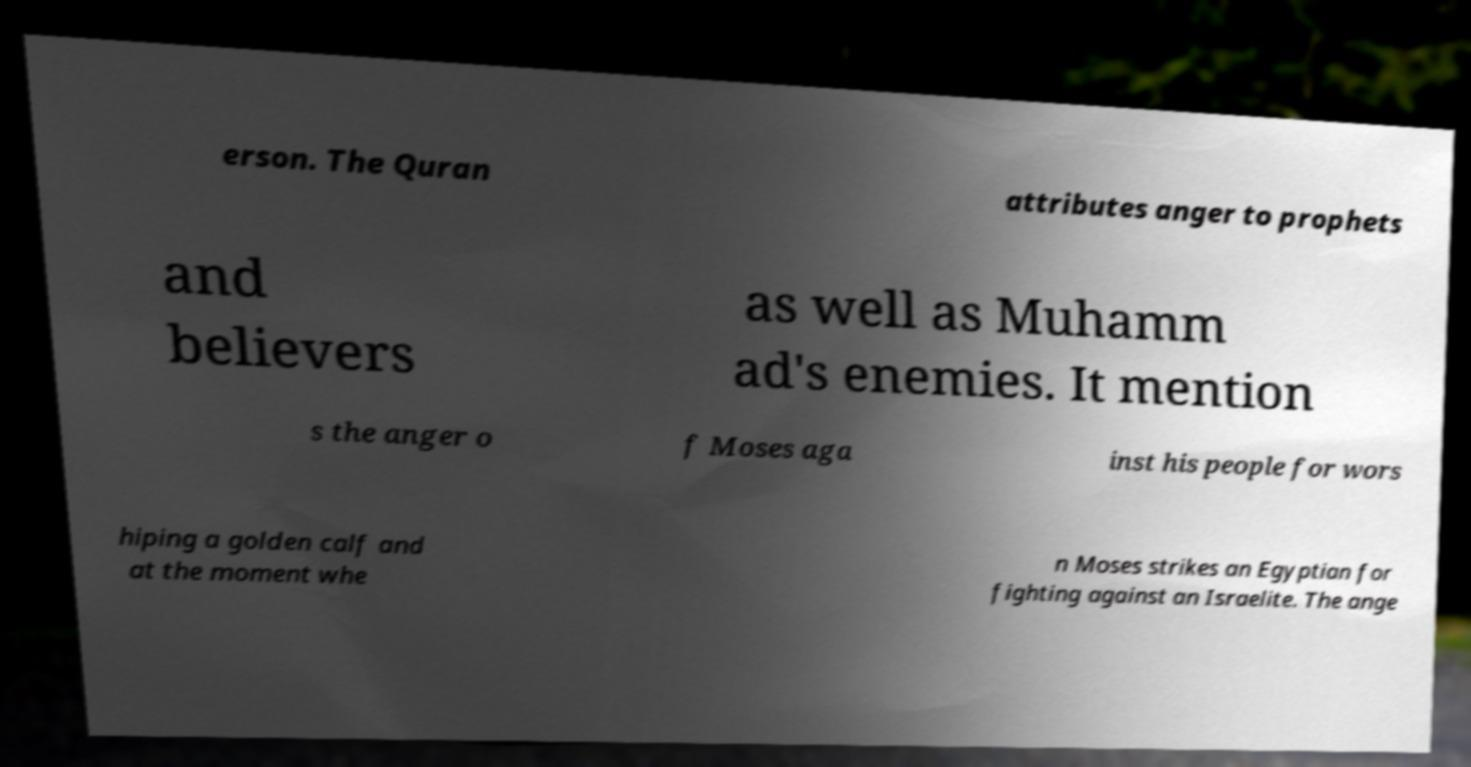There's text embedded in this image that I need extracted. Can you transcribe it verbatim? erson. The Quran attributes anger to prophets and believers as well as Muhamm ad's enemies. It mention s the anger o f Moses aga inst his people for wors hiping a golden calf and at the moment whe n Moses strikes an Egyptian for fighting against an Israelite. The ange 